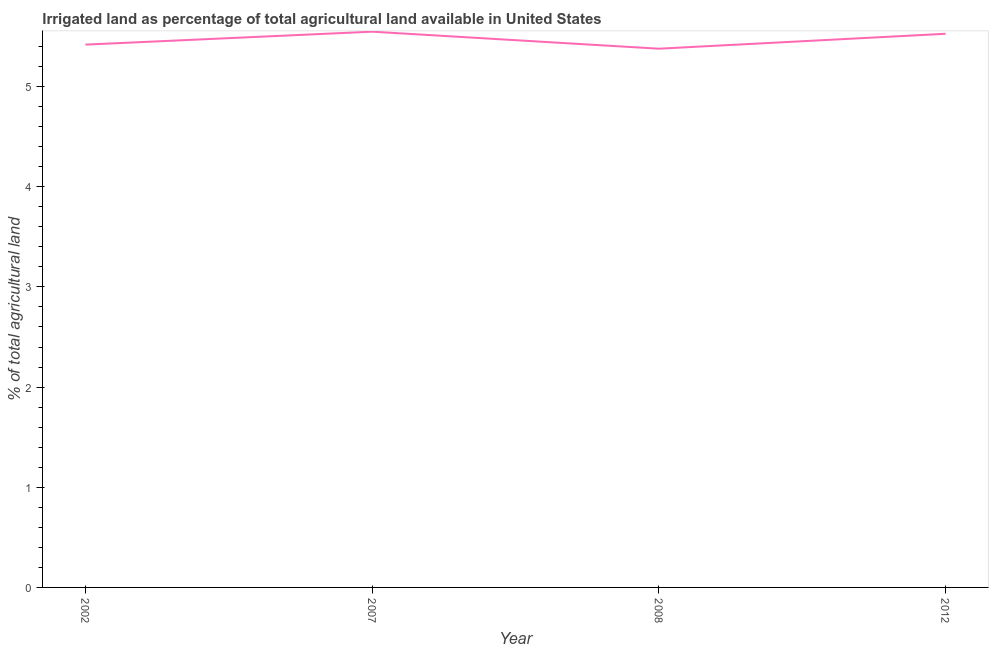What is the percentage of agricultural irrigated land in 2002?
Your answer should be compact. 5.42. Across all years, what is the maximum percentage of agricultural irrigated land?
Your answer should be compact. 5.55. Across all years, what is the minimum percentage of agricultural irrigated land?
Make the answer very short. 5.38. In which year was the percentage of agricultural irrigated land maximum?
Your answer should be compact. 2007. What is the sum of the percentage of agricultural irrigated land?
Make the answer very short. 21.87. What is the difference between the percentage of agricultural irrigated land in 2007 and 2008?
Your answer should be very brief. 0.17. What is the average percentage of agricultural irrigated land per year?
Your response must be concise. 5.47. What is the median percentage of agricultural irrigated land?
Offer a very short reply. 5.47. Do a majority of the years between 2012 and 2007 (inclusive) have percentage of agricultural irrigated land greater than 3 %?
Keep it short and to the point. No. What is the ratio of the percentage of agricultural irrigated land in 2008 to that in 2012?
Your answer should be compact. 0.97. What is the difference between the highest and the second highest percentage of agricultural irrigated land?
Give a very brief answer. 0.02. Is the sum of the percentage of agricultural irrigated land in 2002 and 2007 greater than the maximum percentage of agricultural irrigated land across all years?
Provide a succinct answer. Yes. What is the difference between the highest and the lowest percentage of agricultural irrigated land?
Provide a succinct answer. 0.17. In how many years, is the percentage of agricultural irrigated land greater than the average percentage of agricultural irrigated land taken over all years?
Make the answer very short. 2. How many lines are there?
Provide a short and direct response. 1. What is the difference between two consecutive major ticks on the Y-axis?
Provide a short and direct response. 1. Are the values on the major ticks of Y-axis written in scientific E-notation?
Your response must be concise. No. Does the graph contain any zero values?
Make the answer very short. No. What is the title of the graph?
Give a very brief answer. Irrigated land as percentage of total agricultural land available in United States. What is the label or title of the Y-axis?
Make the answer very short. % of total agricultural land. What is the % of total agricultural land of 2002?
Your response must be concise. 5.42. What is the % of total agricultural land in 2007?
Provide a succinct answer. 5.55. What is the % of total agricultural land in 2008?
Your response must be concise. 5.38. What is the % of total agricultural land of 2012?
Your answer should be very brief. 5.53. What is the difference between the % of total agricultural land in 2002 and 2007?
Offer a terse response. -0.13. What is the difference between the % of total agricultural land in 2002 and 2008?
Your answer should be compact. 0.04. What is the difference between the % of total agricultural land in 2002 and 2012?
Ensure brevity in your answer.  -0.11. What is the difference between the % of total agricultural land in 2007 and 2008?
Your answer should be very brief. 0.17. What is the difference between the % of total agricultural land in 2007 and 2012?
Provide a short and direct response. 0.02. What is the difference between the % of total agricultural land in 2008 and 2012?
Offer a very short reply. -0.15. What is the ratio of the % of total agricultural land in 2002 to that in 2012?
Provide a succinct answer. 0.98. What is the ratio of the % of total agricultural land in 2007 to that in 2008?
Make the answer very short. 1.03. What is the ratio of the % of total agricultural land in 2008 to that in 2012?
Your answer should be very brief. 0.97. 